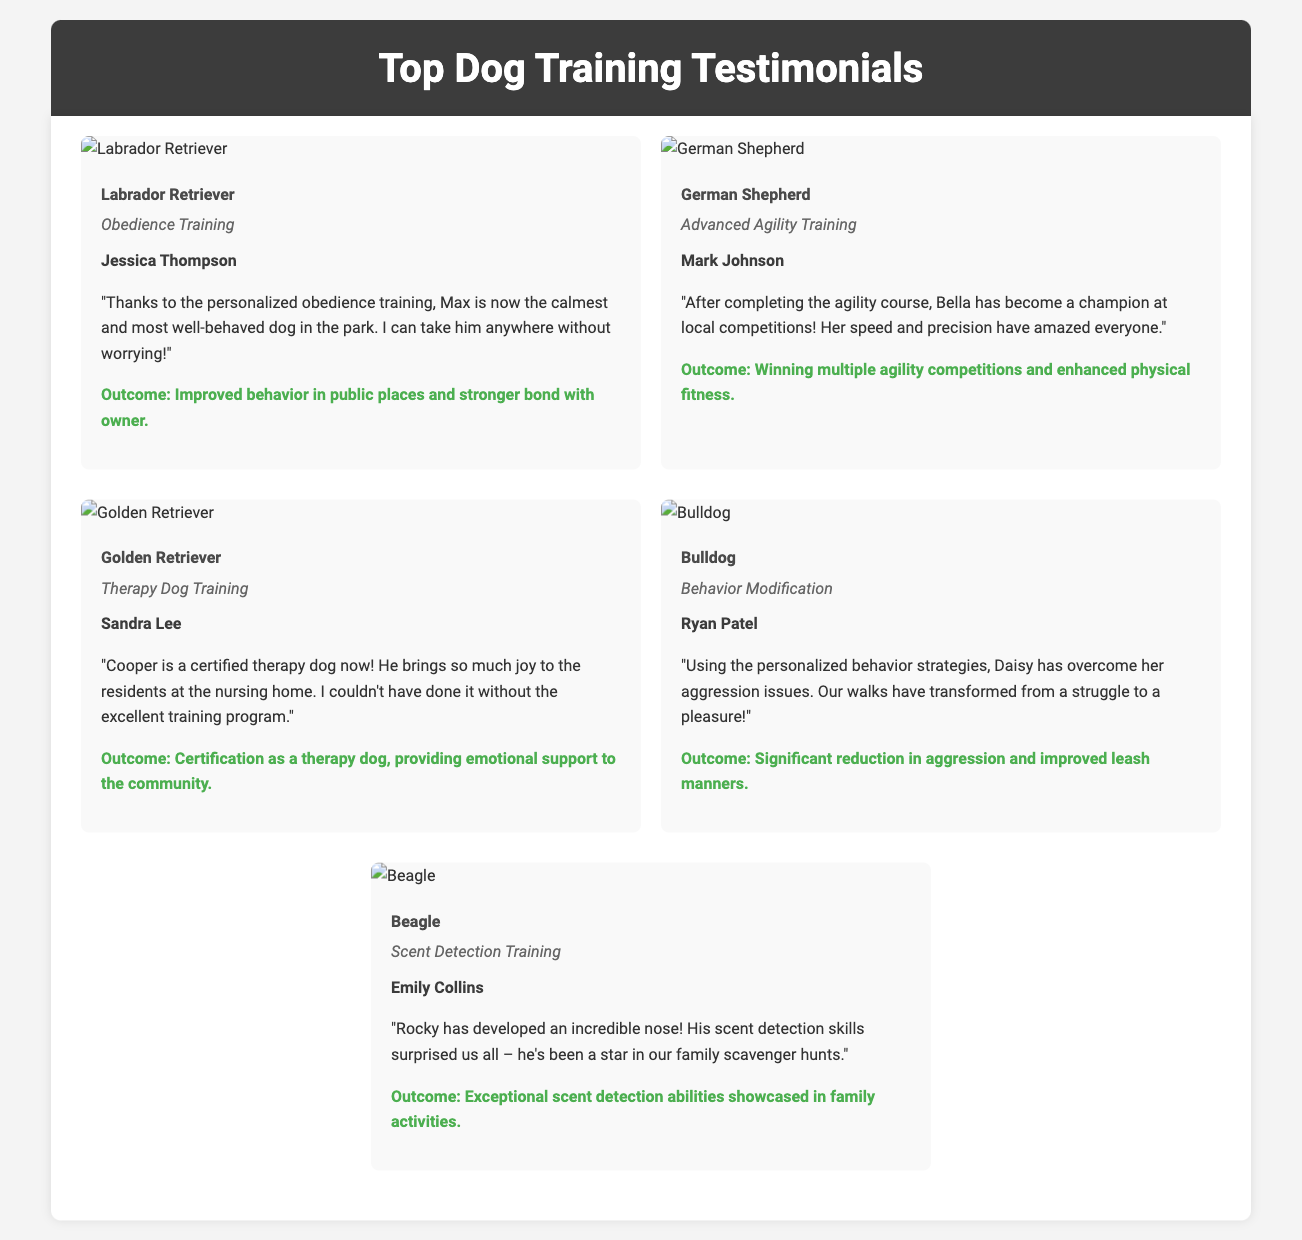What type of training did Max receive? The document states that Max, the Labrador Retriever, underwent Obedience Training.
Answer: Obedience Training Who is the owner of Bella? The testimonial indicates that Bella's owner is Mark Johnson.
Answer: Mark Johnson What breed is Cooper? The document identifies Cooper as a Golden Retriever.
Answer: Golden Retriever What was the outcome for Daisy after training? The document mentions that Daisy had a significant reduction in aggression and improved leash manners.
Answer: Significant reduction in aggression and improved leash manners How many agility competitions has Bella won? The document indicates that Bella has won multiple agility competitions after completing her training.
Answer: Multiple What specific training type helped Rocky develop his skills? The document specifies that Rocky received Scent Detection Training.
Answer: Scent Detection Training Which dog breed is associated with therapy dog training? The document states that Cooper, a Golden Retriever, is associated with therapy dog training.
Answer: Golden Retriever What positive effect did training have on Max’s behavior? According to the document, Max's training led to improved behavior in public places and a stronger bond with his owner.
Answer: Improved behavior in public places and stronger bond with owner 